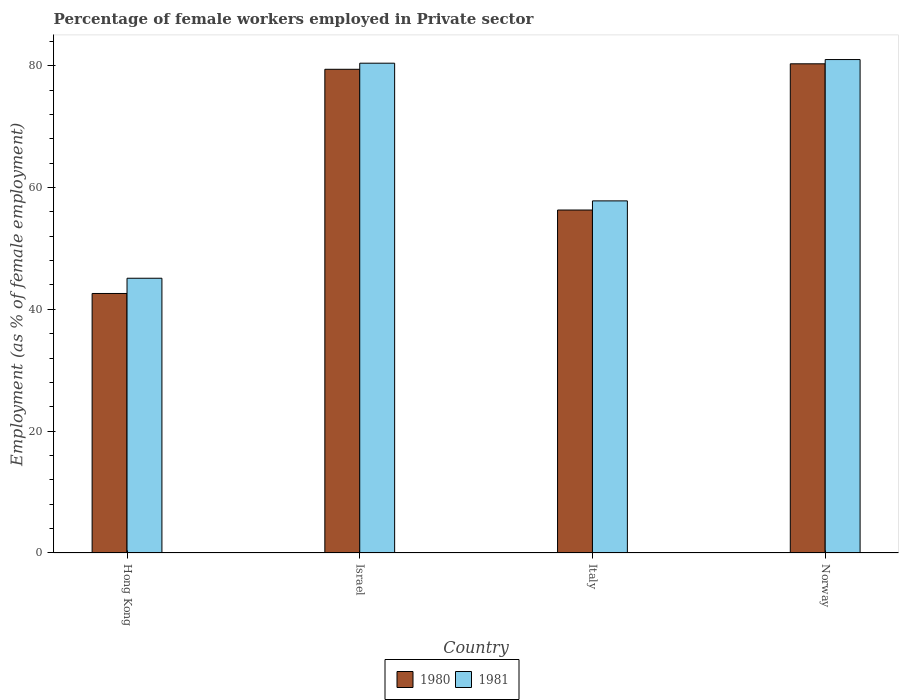How many groups of bars are there?
Keep it short and to the point. 4. Are the number of bars per tick equal to the number of legend labels?
Your response must be concise. Yes. How many bars are there on the 4th tick from the left?
Give a very brief answer. 2. How many bars are there on the 3rd tick from the right?
Offer a very short reply. 2. What is the label of the 1st group of bars from the left?
Keep it short and to the point. Hong Kong. In how many cases, is the number of bars for a given country not equal to the number of legend labels?
Ensure brevity in your answer.  0. What is the percentage of females employed in Private sector in 1980 in Hong Kong?
Your response must be concise. 42.6. Across all countries, what is the maximum percentage of females employed in Private sector in 1980?
Provide a short and direct response. 80.3. Across all countries, what is the minimum percentage of females employed in Private sector in 1980?
Your answer should be compact. 42.6. In which country was the percentage of females employed in Private sector in 1981 minimum?
Your answer should be compact. Hong Kong. What is the total percentage of females employed in Private sector in 1980 in the graph?
Give a very brief answer. 258.6. What is the difference between the percentage of females employed in Private sector in 1981 in Israel and that in Norway?
Make the answer very short. -0.6. What is the difference between the percentage of females employed in Private sector in 1980 in Israel and the percentage of females employed in Private sector in 1981 in Italy?
Your response must be concise. 21.6. What is the average percentage of females employed in Private sector in 1981 per country?
Keep it short and to the point. 66.07. In how many countries, is the percentage of females employed in Private sector in 1981 greater than 4 %?
Offer a terse response. 4. What is the ratio of the percentage of females employed in Private sector in 1981 in Italy to that in Norway?
Your response must be concise. 0.71. Is the difference between the percentage of females employed in Private sector in 1981 in Hong Kong and Israel greater than the difference between the percentage of females employed in Private sector in 1980 in Hong Kong and Israel?
Make the answer very short. Yes. What is the difference between the highest and the second highest percentage of females employed in Private sector in 1981?
Make the answer very short. -0.6. What is the difference between the highest and the lowest percentage of females employed in Private sector in 1981?
Your answer should be compact. 35.9. Is the sum of the percentage of females employed in Private sector in 1980 in Hong Kong and Israel greater than the maximum percentage of females employed in Private sector in 1981 across all countries?
Keep it short and to the point. Yes. What does the 2nd bar from the left in Israel represents?
Make the answer very short. 1981. How many bars are there?
Provide a short and direct response. 8. How many countries are there in the graph?
Offer a very short reply. 4. Does the graph contain any zero values?
Ensure brevity in your answer.  No. How are the legend labels stacked?
Keep it short and to the point. Horizontal. What is the title of the graph?
Offer a terse response. Percentage of female workers employed in Private sector. What is the label or title of the X-axis?
Keep it short and to the point. Country. What is the label or title of the Y-axis?
Make the answer very short. Employment (as % of female employment). What is the Employment (as % of female employment) in 1980 in Hong Kong?
Keep it short and to the point. 42.6. What is the Employment (as % of female employment) in 1981 in Hong Kong?
Your response must be concise. 45.1. What is the Employment (as % of female employment) of 1980 in Israel?
Offer a terse response. 79.4. What is the Employment (as % of female employment) of 1981 in Israel?
Your response must be concise. 80.4. What is the Employment (as % of female employment) in 1980 in Italy?
Give a very brief answer. 56.3. What is the Employment (as % of female employment) of 1981 in Italy?
Offer a terse response. 57.8. What is the Employment (as % of female employment) in 1980 in Norway?
Your response must be concise. 80.3. What is the Employment (as % of female employment) of 1981 in Norway?
Keep it short and to the point. 81. Across all countries, what is the maximum Employment (as % of female employment) in 1980?
Make the answer very short. 80.3. Across all countries, what is the minimum Employment (as % of female employment) of 1980?
Provide a short and direct response. 42.6. Across all countries, what is the minimum Employment (as % of female employment) in 1981?
Your response must be concise. 45.1. What is the total Employment (as % of female employment) in 1980 in the graph?
Your answer should be very brief. 258.6. What is the total Employment (as % of female employment) of 1981 in the graph?
Keep it short and to the point. 264.3. What is the difference between the Employment (as % of female employment) of 1980 in Hong Kong and that in Israel?
Your response must be concise. -36.8. What is the difference between the Employment (as % of female employment) in 1981 in Hong Kong and that in Israel?
Keep it short and to the point. -35.3. What is the difference between the Employment (as % of female employment) of 1980 in Hong Kong and that in Italy?
Offer a very short reply. -13.7. What is the difference between the Employment (as % of female employment) in 1980 in Hong Kong and that in Norway?
Give a very brief answer. -37.7. What is the difference between the Employment (as % of female employment) in 1981 in Hong Kong and that in Norway?
Your answer should be compact. -35.9. What is the difference between the Employment (as % of female employment) in 1980 in Israel and that in Italy?
Provide a short and direct response. 23.1. What is the difference between the Employment (as % of female employment) of 1981 in Israel and that in Italy?
Provide a succinct answer. 22.6. What is the difference between the Employment (as % of female employment) of 1980 in Israel and that in Norway?
Offer a terse response. -0.9. What is the difference between the Employment (as % of female employment) of 1981 in Israel and that in Norway?
Make the answer very short. -0.6. What is the difference between the Employment (as % of female employment) of 1980 in Italy and that in Norway?
Your answer should be compact. -24. What is the difference between the Employment (as % of female employment) of 1981 in Italy and that in Norway?
Make the answer very short. -23.2. What is the difference between the Employment (as % of female employment) in 1980 in Hong Kong and the Employment (as % of female employment) in 1981 in Israel?
Give a very brief answer. -37.8. What is the difference between the Employment (as % of female employment) of 1980 in Hong Kong and the Employment (as % of female employment) of 1981 in Italy?
Your answer should be compact. -15.2. What is the difference between the Employment (as % of female employment) in 1980 in Hong Kong and the Employment (as % of female employment) in 1981 in Norway?
Provide a succinct answer. -38.4. What is the difference between the Employment (as % of female employment) in 1980 in Israel and the Employment (as % of female employment) in 1981 in Italy?
Your answer should be very brief. 21.6. What is the difference between the Employment (as % of female employment) of 1980 in Israel and the Employment (as % of female employment) of 1981 in Norway?
Provide a short and direct response. -1.6. What is the difference between the Employment (as % of female employment) of 1980 in Italy and the Employment (as % of female employment) of 1981 in Norway?
Provide a succinct answer. -24.7. What is the average Employment (as % of female employment) of 1980 per country?
Keep it short and to the point. 64.65. What is the average Employment (as % of female employment) in 1981 per country?
Make the answer very short. 66.08. What is the difference between the Employment (as % of female employment) in 1980 and Employment (as % of female employment) in 1981 in Israel?
Give a very brief answer. -1. What is the difference between the Employment (as % of female employment) in 1980 and Employment (as % of female employment) in 1981 in Norway?
Your response must be concise. -0.7. What is the ratio of the Employment (as % of female employment) of 1980 in Hong Kong to that in Israel?
Ensure brevity in your answer.  0.54. What is the ratio of the Employment (as % of female employment) of 1981 in Hong Kong to that in Israel?
Make the answer very short. 0.56. What is the ratio of the Employment (as % of female employment) in 1980 in Hong Kong to that in Italy?
Your answer should be very brief. 0.76. What is the ratio of the Employment (as % of female employment) in 1981 in Hong Kong to that in Italy?
Keep it short and to the point. 0.78. What is the ratio of the Employment (as % of female employment) of 1980 in Hong Kong to that in Norway?
Offer a terse response. 0.53. What is the ratio of the Employment (as % of female employment) of 1981 in Hong Kong to that in Norway?
Offer a very short reply. 0.56. What is the ratio of the Employment (as % of female employment) of 1980 in Israel to that in Italy?
Your response must be concise. 1.41. What is the ratio of the Employment (as % of female employment) in 1981 in Israel to that in Italy?
Provide a short and direct response. 1.39. What is the ratio of the Employment (as % of female employment) of 1980 in Israel to that in Norway?
Make the answer very short. 0.99. What is the ratio of the Employment (as % of female employment) in 1980 in Italy to that in Norway?
Your answer should be compact. 0.7. What is the ratio of the Employment (as % of female employment) of 1981 in Italy to that in Norway?
Offer a terse response. 0.71. What is the difference between the highest and the lowest Employment (as % of female employment) of 1980?
Provide a short and direct response. 37.7. What is the difference between the highest and the lowest Employment (as % of female employment) of 1981?
Your answer should be very brief. 35.9. 